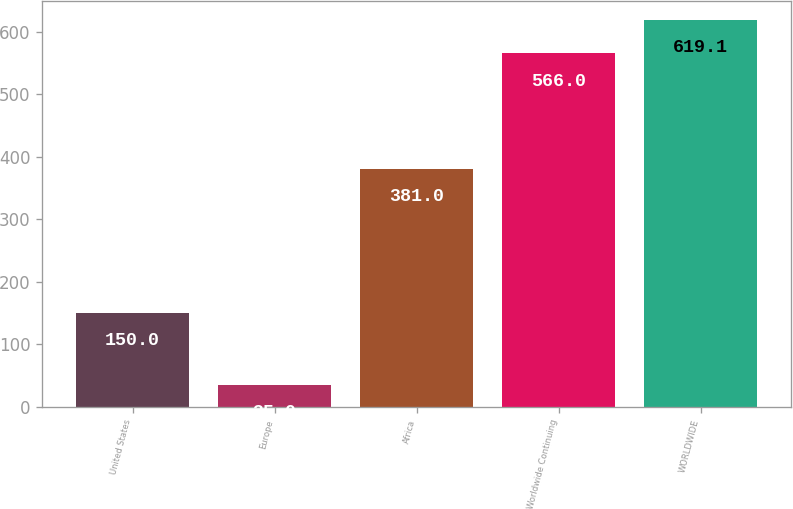Convert chart to OTSL. <chart><loc_0><loc_0><loc_500><loc_500><bar_chart><fcel>United States<fcel>Europe<fcel>Africa<fcel>Worldwide Continuing<fcel>WORLDWIDE<nl><fcel>150<fcel>35<fcel>381<fcel>566<fcel>619.1<nl></chart> 